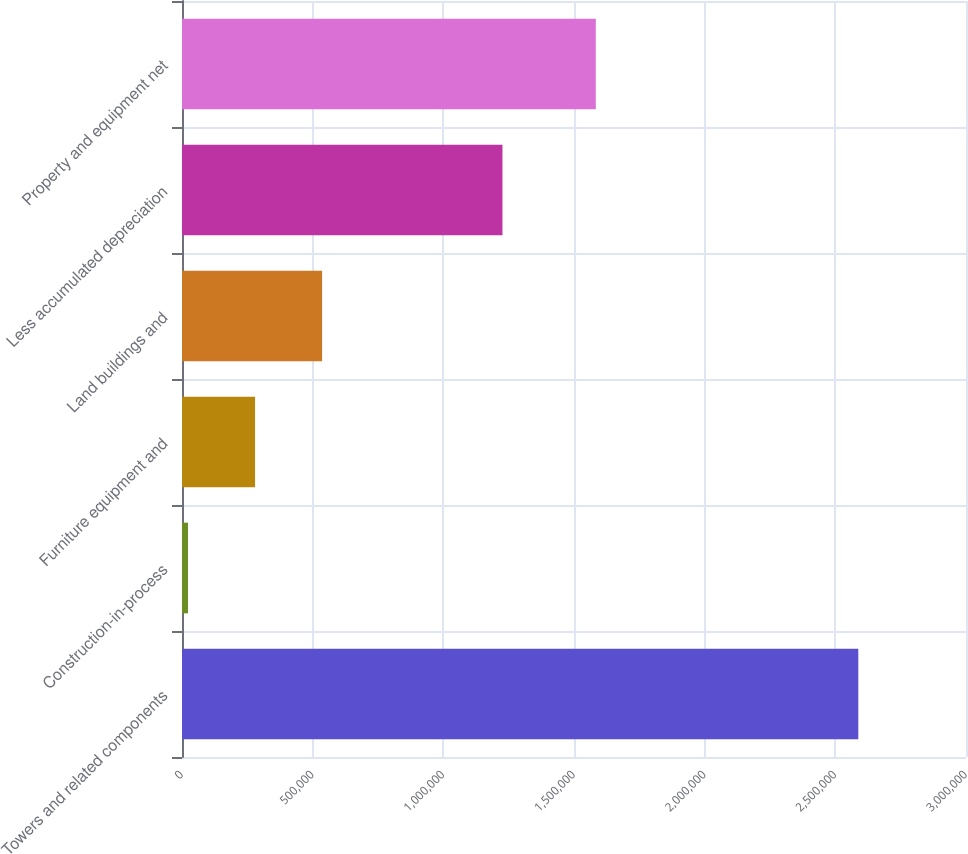Convert chart. <chart><loc_0><loc_0><loc_500><loc_500><bar_chart><fcel>Towers and related components<fcel>Construction-in-process<fcel>Furniture equipment and<fcel>Land buildings and<fcel>Less accumulated depreciation<fcel>Property and equipment net<nl><fcel>2.5879e+06<fcel>23076<fcel>279558<fcel>536040<fcel>1.22628e+06<fcel>1.58339e+06<nl></chart> 